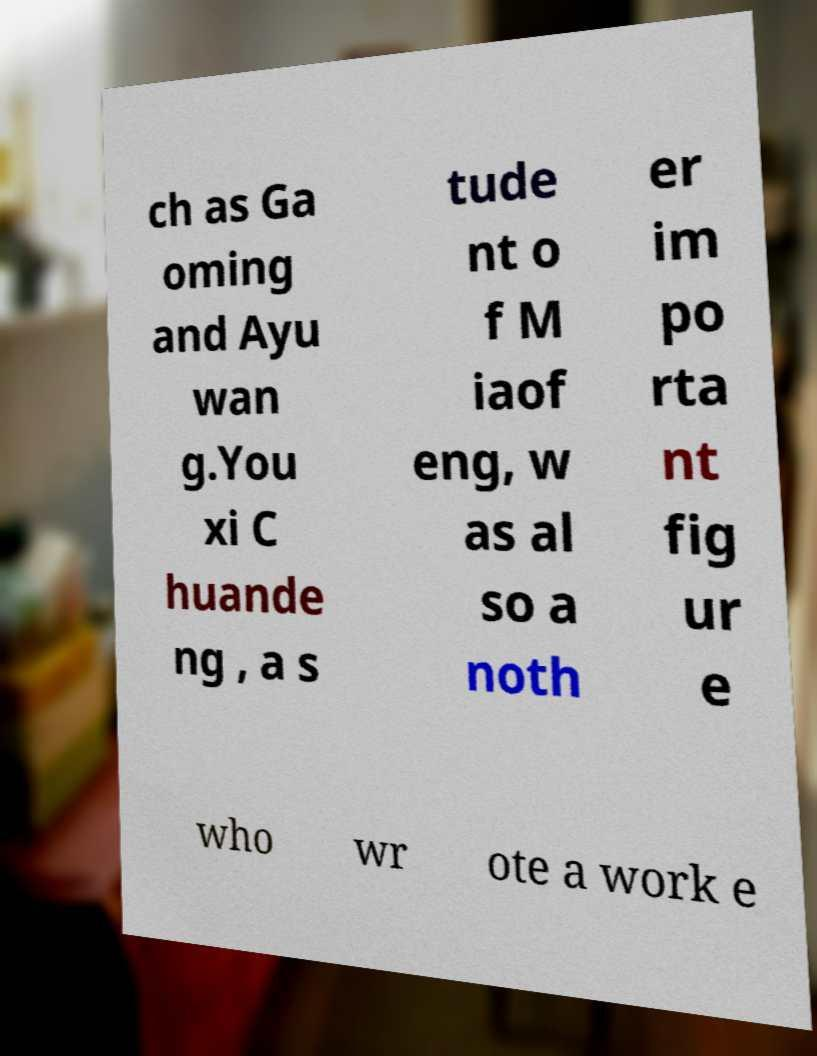Could you assist in decoding the text presented in this image and type it out clearly? ch as Ga oming and Ayu wan g.You xi C huande ng , a s tude nt o f M iaof eng, w as al so a noth er im po rta nt fig ur e who wr ote a work e 